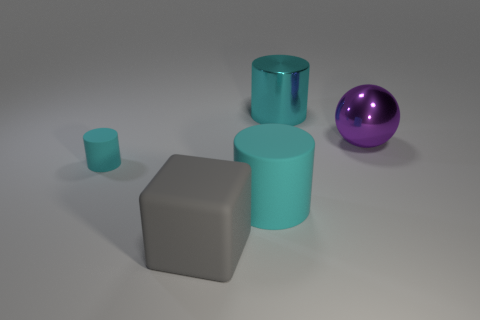What is the material of the ball?
Your answer should be very brief. Metal. There is a large cyan cylinder on the left side of the cyan object that is on the right side of the big cyan object in front of the big shiny sphere; what is it made of?
Make the answer very short. Rubber. There is a shiny thing that is the same size as the purple metallic ball; what is its shape?
Make the answer very short. Cylinder. How many things are gray shiny cubes or large objects that are to the right of the large rubber cylinder?
Provide a short and direct response. 2. Do the cyan cylinder that is to the left of the large gray rubber cube and the cylinder that is in front of the tiny cyan thing have the same material?
Give a very brief answer. Yes. What is the shape of the big metal object that is the same color as the small matte object?
Provide a succinct answer. Cylinder. What number of yellow objects are either large metallic balls or matte blocks?
Make the answer very short. 0. Are there more cyan things that are behind the tiny matte cylinder than small purple spheres?
Your response must be concise. Yes. There is a large purple metallic ball; how many gray cubes are to the right of it?
Give a very brief answer. 0. Is there a purple shiny ball of the same size as the cube?
Provide a short and direct response. Yes. 